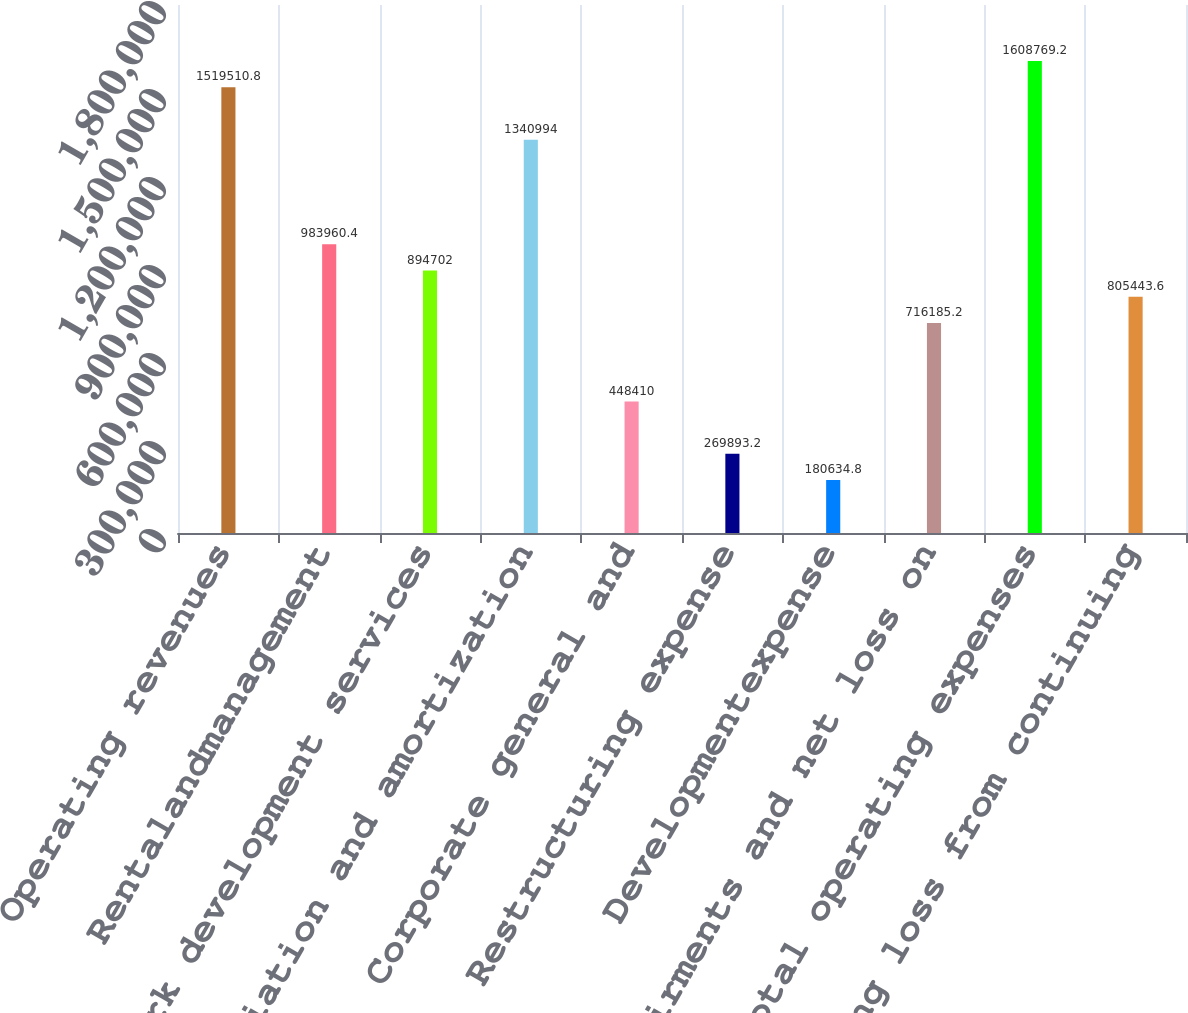Convert chart. <chart><loc_0><loc_0><loc_500><loc_500><bar_chart><fcel>Operating revenues<fcel>Rentalandmanagement<fcel>Network development services<fcel>Depreciation and amortization<fcel>Corporate general and<fcel>Restructuring expense<fcel>Developmentexpense<fcel>Impairments and net loss on<fcel>Total operating expenses<fcel>Operating loss from continuing<nl><fcel>1.51951e+06<fcel>983960<fcel>894702<fcel>1.34099e+06<fcel>448410<fcel>269893<fcel>180635<fcel>716185<fcel>1.60877e+06<fcel>805444<nl></chart> 